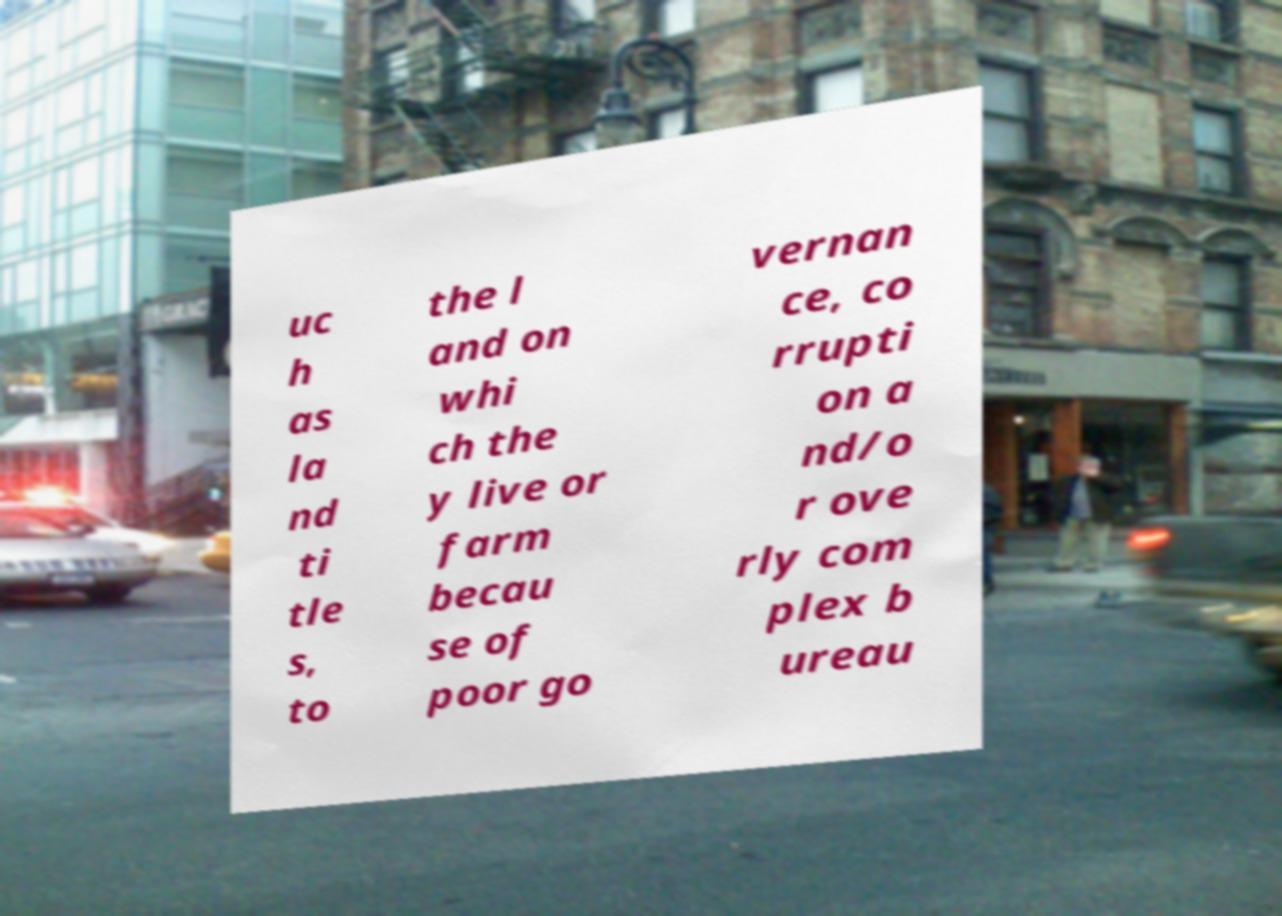Please identify and transcribe the text found in this image. uc h as la nd ti tle s, to the l and on whi ch the y live or farm becau se of poor go vernan ce, co rrupti on a nd/o r ove rly com plex b ureau 